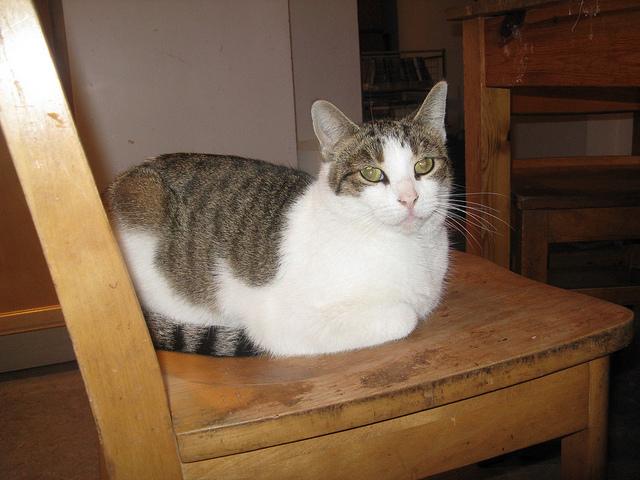What furniture is the cat on?
Answer briefly. Chair. What colors are the cat?
Be succinct. Brown and white. Does this animal bark?
Quick response, please. No. 